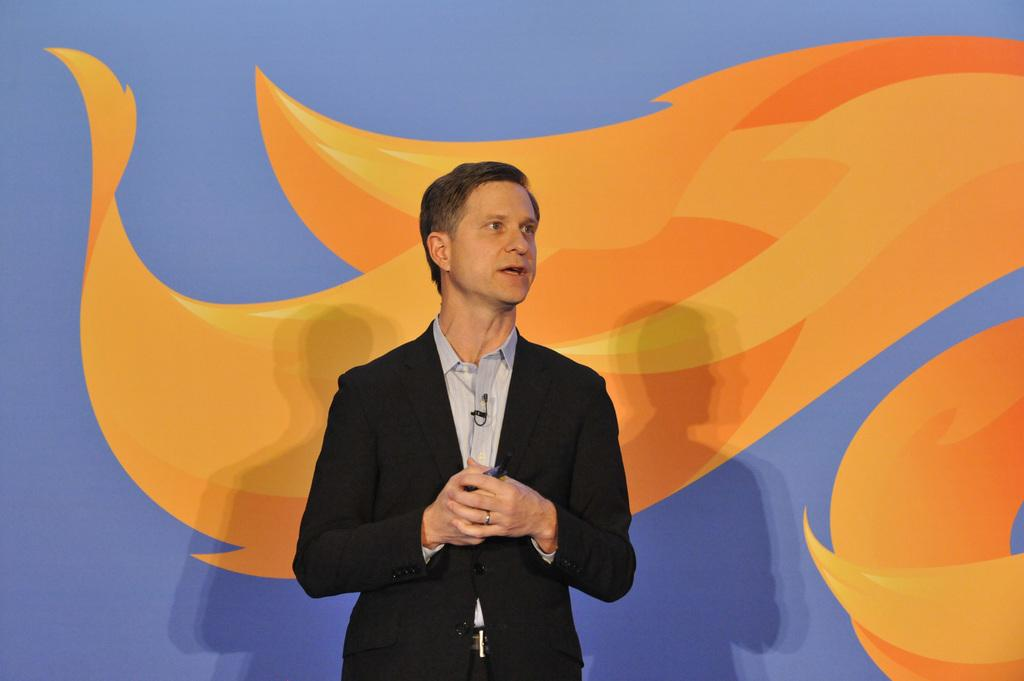Where was the image taken? The image is taken indoors. What can be seen in the background of the image? There is a wall with a painting in the background. What is the man in the image doing? The man is standing and talking in the middle of the image. What type of clothing is the man wearing? The man is wearing a coat and a shirt. What type of base is visible in the image? There is no base present in the image. Is there an alarm going off in the image? There is no alarm or any indication of an alarm in the image. 